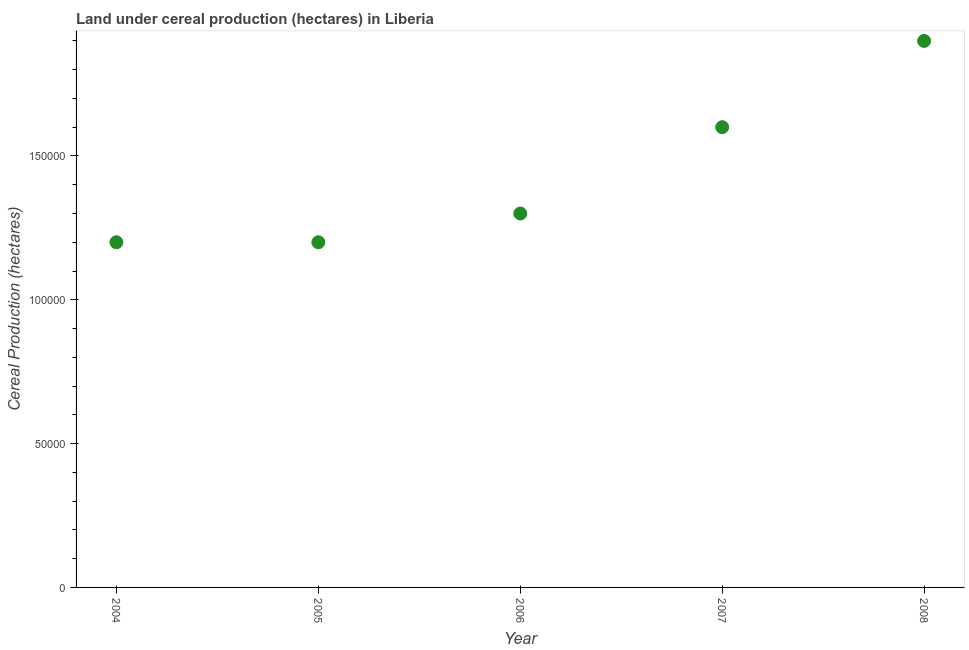What is the land under cereal production in 2005?
Provide a succinct answer. 1.20e+05. Across all years, what is the maximum land under cereal production?
Offer a very short reply. 1.90e+05. Across all years, what is the minimum land under cereal production?
Provide a short and direct response. 1.20e+05. In which year was the land under cereal production maximum?
Your answer should be very brief. 2008. What is the sum of the land under cereal production?
Offer a terse response. 7.20e+05. What is the difference between the land under cereal production in 2006 and 2007?
Provide a short and direct response. -3.00e+04. What is the average land under cereal production per year?
Offer a terse response. 1.44e+05. What is the median land under cereal production?
Ensure brevity in your answer.  1.30e+05. Do a majority of the years between 2006 and 2007 (inclusive) have land under cereal production greater than 60000 hectares?
Make the answer very short. Yes. What is the ratio of the land under cereal production in 2004 to that in 2005?
Your response must be concise. 1. Is the land under cereal production in 2004 less than that in 2006?
Offer a very short reply. Yes. Is the difference between the land under cereal production in 2006 and 2007 greater than the difference between any two years?
Offer a terse response. No. Is the sum of the land under cereal production in 2006 and 2007 greater than the maximum land under cereal production across all years?
Provide a short and direct response. Yes. What is the difference between the highest and the lowest land under cereal production?
Provide a short and direct response. 7.00e+04. How many years are there in the graph?
Provide a succinct answer. 5. Does the graph contain any zero values?
Your answer should be very brief. No. What is the title of the graph?
Keep it short and to the point. Land under cereal production (hectares) in Liberia. What is the label or title of the Y-axis?
Make the answer very short. Cereal Production (hectares). What is the Cereal Production (hectares) in 2007?
Offer a very short reply. 1.60e+05. What is the Cereal Production (hectares) in 2008?
Give a very brief answer. 1.90e+05. What is the difference between the Cereal Production (hectares) in 2004 and 2005?
Keep it short and to the point. 0. What is the difference between the Cereal Production (hectares) in 2004 and 2006?
Your answer should be compact. -10000. What is the difference between the Cereal Production (hectares) in 2004 and 2007?
Offer a terse response. -4.00e+04. What is the difference between the Cereal Production (hectares) in 2005 and 2007?
Give a very brief answer. -4.00e+04. What is the difference between the Cereal Production (hectares) in 2005 and 2008?
Your response must be concise. -7.00e+04. What is the difference between the Cereal Production (hectares) in 2006 and 2007?
Provide a succinct answer. -3.00e+04. What is the ratio of the Cereal Production (hectares) in 2004 to that in 2005?
Provide a short and direct response. 1. What is the ratio of the Cereal Production (hectares) in 2004 to that in 2006?
Keep it short and to the point. 0.92. What is the ratio of the Cereal Production (hectares) in 2004 to that in 2008?
Provide a succinct answer. 0.63. What is the ratio of the Cereal Production (hectares) in 2005 to that in 2006?
Give a very brief answer. 0.92. What is the ratio of the Cereal Production (hectares) in 2005 to that in 2007?
Give a very brief answer. 0.75. What is the ratio of the Cereal Production (hectares) in 2005 to that in 2008?
Your answer should be very brief. 0.63. What is the ratio of the Cereal Production (hectares) in 2006 to that in 2007?
Provide a succinct answer. 0.81. What is the ratio of the Cereal Production (hectares) in 2006 to that in 2008?
Offer a very short reply. 0.68. What is the ratio of the Cereal Production (hectares) in 2007 to that in 2008?
Make the answer very short. 0.84. 